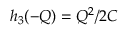Convert formula to latex. <formula><loc_0><loc_0><loc_500><loc_500>h _ { 3 } ( - Q ) = Q ^ { 2 } / 2 C</formula> 